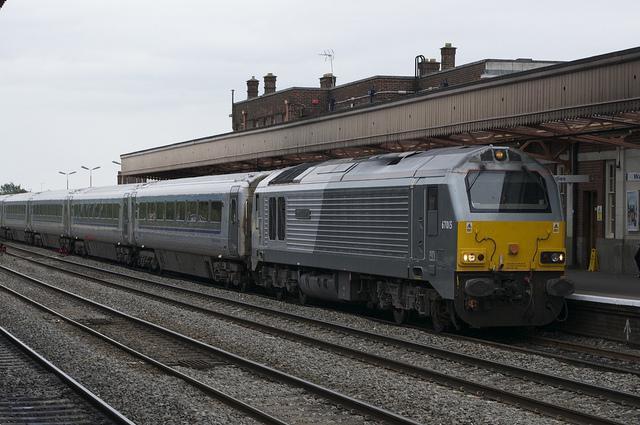How many trucks of rail are there?
Give a very brief answer. 4. How many  Railroad  are there?
Give a very brief answer. 4. How many different trains are on the tracks?
Give a very brief answer. 1. How many sets of tracks are there?
Give a very brief answer. 4. How many train tracks do you see?
Give a very brief answer. 4. How many trains are there in the picture?
Give a very brief answer. 1. How many cars are there?
Give a very brief answer. 5. 